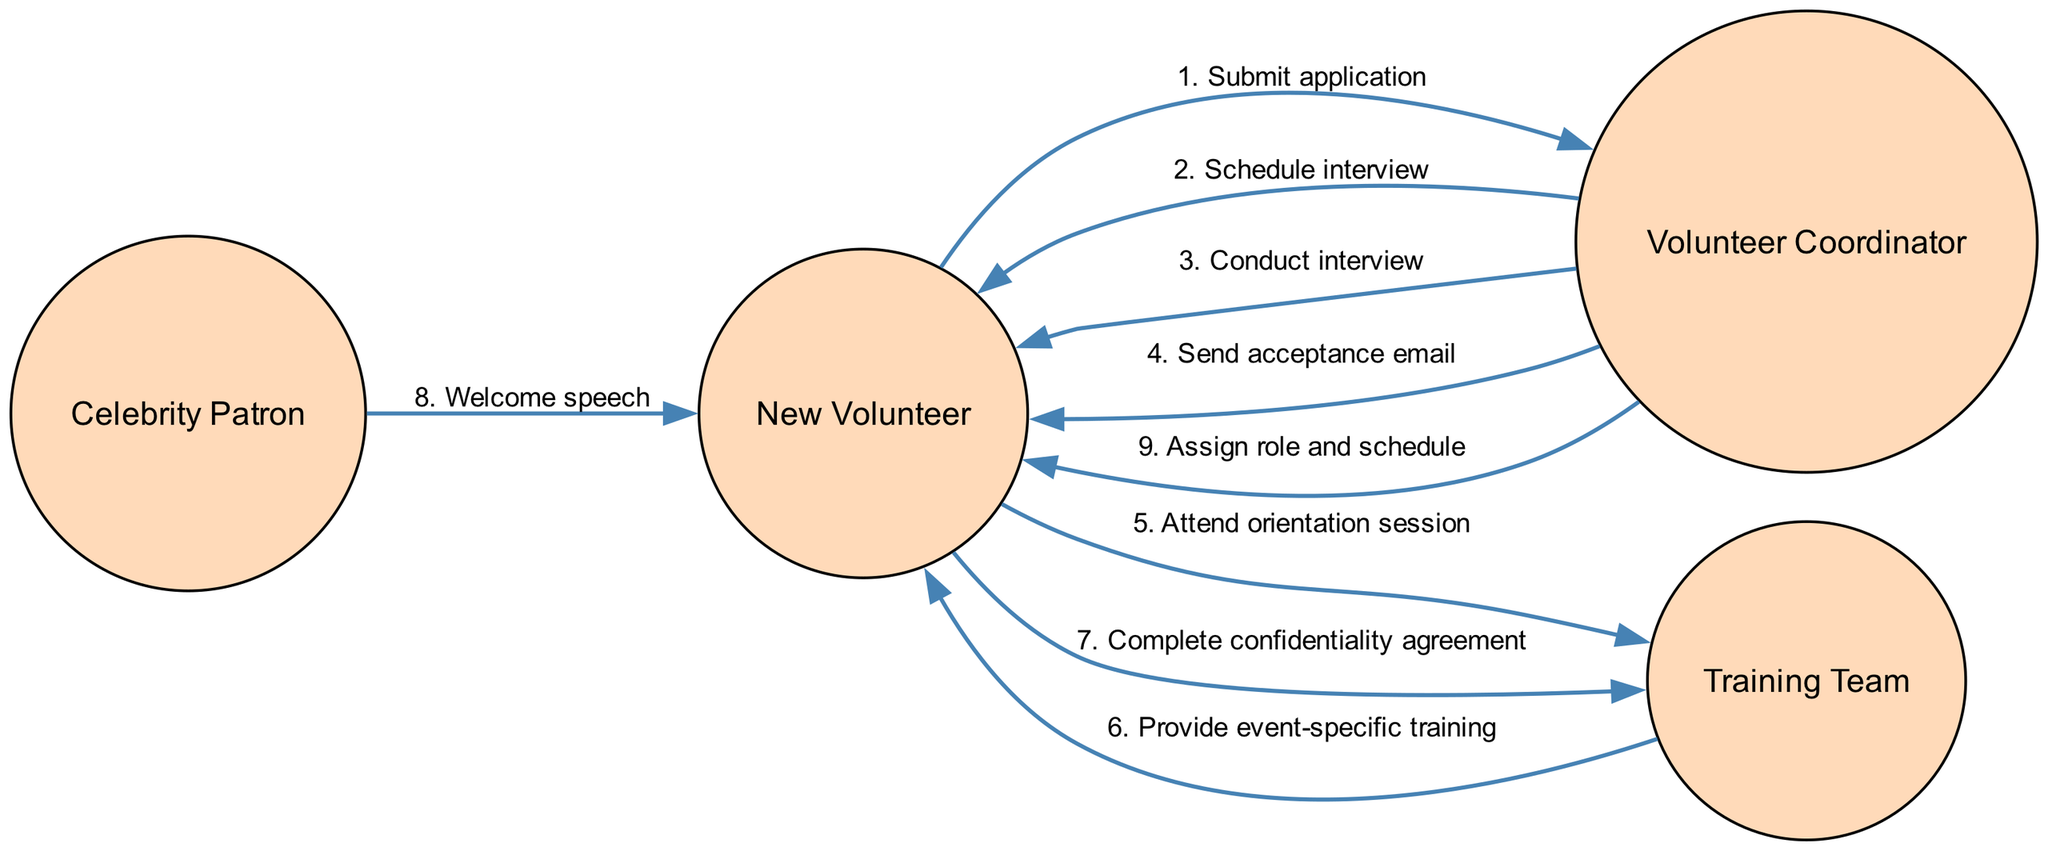What is the first action taken by the New Volunteer? The first action taken by the New Volunteer is to submit an application to the Volunteer Coordinator. This is indicated as the first step in the sequence diagram.
Answer: Submit application How many actors are involved in the onboarding process? The diagram lists four distinct actors: Celebrity Patron, Volunteer Coordinator, New Volunteer, and Training Team, indicating there are four actors involved in the process.
Answer: Four What is the last message sent in the sequence? The last message sent in the sequence is "Assign role and schedule" from the Volunteer Coordinator to the New Volunteer, which is the final step in the onboarding process.
Answer: Assign role and schedule Which actor conducts the interview? The Volunteer Coordinator is responsible for conducting the interview as shown in the sequence diagram where the message "Conduct interview" is sent from the Volunteer Coordinator to the New Volunteer.
Answer: Volunteer Coordinator How many messages are exchanged between the New Volunteer and the Training Team? There are two messages exchanged between the New Volunteer and the Training Team: "Attend orientation session" and "Complete confidentiality agreement", indicating two exchanges.
Answer: Two What is the primary purpose of the welcome speech given by the Celebrity Patron? The welcome speech serves as a formal greeting and encouragement to the New Volunteer, motivating them as they begin their role in the charity event. It signifies the involvement of the Celebrity Patron and welcomes the volunteers.
Answer: Welcome speech Which step in the sequence occurs directly after the New Volunteer attends the orientation session? After the New Volunteer attends the orientation session, the next step is "Provide event-specific training" delivered by the Training Team, which follows the orientation session.
Answer: Provide event-specific training What role does the Volunteer Coordinator play in this process? The Volunteer Coordinator manages multiple steps, including scheduling the interview, conducting the interview, sending an acceptance email, and assigning roles and schedules, showing their central role in coordinating the onboarding process.
Answer: Manages the onboarding process 